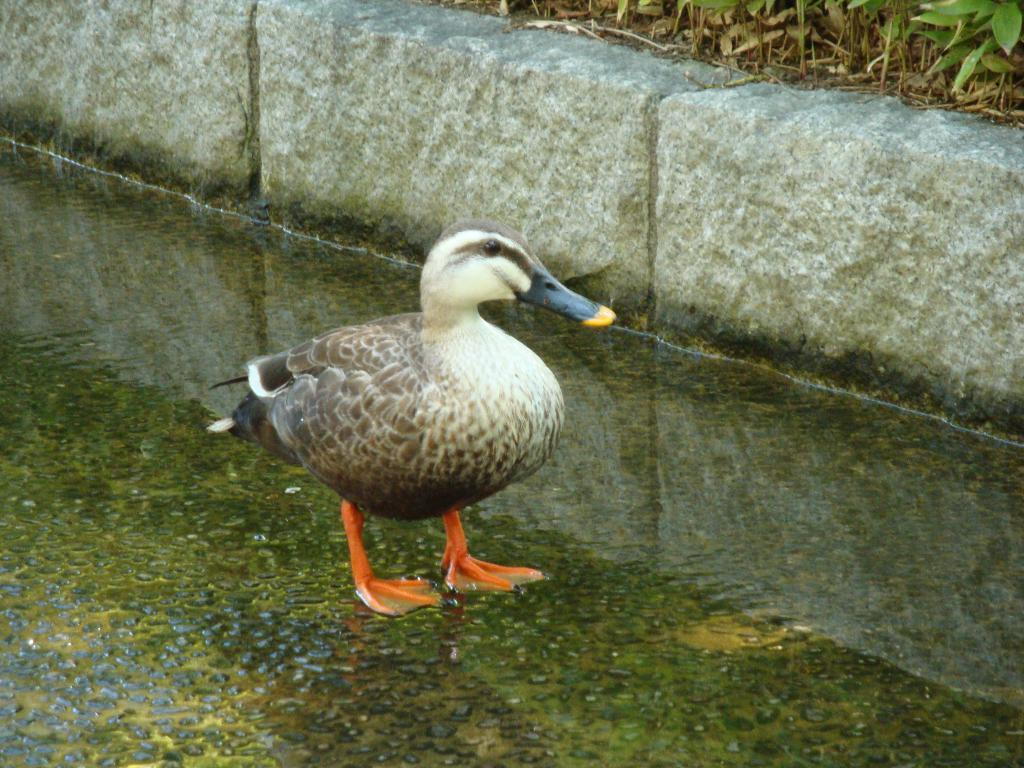What type of animal is in the image? There is a bird in the image. What colors can be seen on the bird? The bird has brown and white colors. Where is the bird located in the image? The bird is standing in the water. What can be seen in the background of the image? There are trees in the background of the image. What color are the trees? The trees have green colors. What type of ticket is the bird holding in the image? There is no ticket present in the image; it features a bird standing in the water. What month is it in the image? The image does not provide information about the month or time of year. 